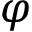Convert formula to latex. <formula><loc_0><loc_0><loc_500><loc_500>\varphi</formula> 